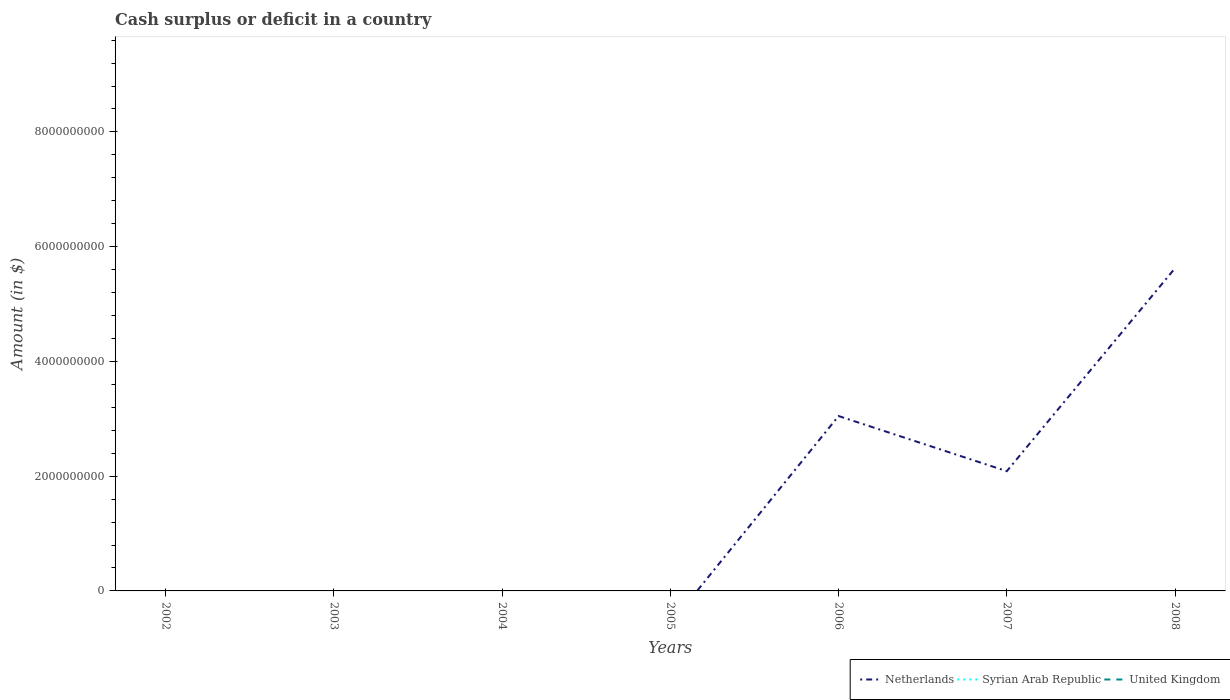Is the number of lines equal to the number of legend labels?
Offer a terse response. No. What is the difference between the highest and the second highest amount of cash surplus or deficit in Netherlands?
Ensure brevity in your answer.  5.62e+09. Is the amount of cash surplus or deficit in Netherlands strictly greater than the amount of cash surplus or deficit in Syrian Arab Republic over the years?
Ensure brevity in your answer.  No. Does the graph contain any zero values?
Your answer should be compact. Yes. Does the graph contain grids?
Your answer should be compact. No. How many legend labels are there?
Offer a terse response. 3. What is the title of the graph?
Keep it short and to the point. Cash surplus or deficit in a country. What is the label or title of the Y-axis?
Keep it short and to the point. Amount (in $). What is the Amount (in $) of Netherlands in 2003?
Give a very brief answer. 0. What is the Amount (in $) of Syrian Arab Republic in 2003?
Make the answer very short. 0. What is the Amount (in $) of United Kingdom in 2003?
Offer a terse response. 0. What is the Amount (in $) in United Kingdom in 2005?
Keep it short and to the point. 0. What is the Amount (in $) in Netherlands in 2006?
Give a very brief answer. 3.05e+09. What is the Amount (in $) of Syrian Arab Republic in 2006?
Your response must be concise. 0. What is the Amount (in $) of Netherlands in 2007?
Your answer should be very brief. 2.09e+09. What is the Amount (in $) in Syrian Arab Republic in 2007?
Ensure brevity in your answer.  0. What is the Amount (in $) of United Kingdom in 2007?
Keep it short and to the point. 0. What is the Amount (in $) of Netherlands in 2008?
Keep it short and to the point. 5.62e+09. Across all years, what is the maximum Amount (in $) in Netherlands?
Offer a terse response. 5.62e+09. Across all years, what is the minimum Amount (in $) of Netherlands?
Your answer should be compact. 0. What is the total Amount (in $) of Netherlands in the graph?
Offer a terse response. 1.08e+1. What is the total Amount (in $) in Syrian Arab Republic in the graph?
Offer a terse response. 0. What is the total Amount (in $) in United Kingdom in the graph?
Your answer should be very brief. 0. What is the difference between the Amount (in $) of Netherlands in 2006 and that in 2007?
Keep it short and to the point. 9.61e+08. What is the difference between the Amount (in $) in Netherlands in 2006 and that in 2008?
Make the answer very short. -2.58e+09. What is the difference between the Amount (in $) in Netherlands in 2007 and that in 2008?
Provide a succinct answer. -3.54e+09. What is the average Amount (in $) of Netherlands per year?
Give a very brief answer. 1.54e+09. What is the average Amount (in $) of Syrian Arab Republic per year?
Give a very brief answer. 0. What is the ratio of the Amount (in $) of Netherlands in 2006 to that in 2007?
Keep it short and to the point. 1.46. What is the ratio of the Amount (in $) of Netherlands in 2006 to that in 2008?
Your answer should be compact. 0.54. What is the ratio of the Amount (in $) in Netherlands in 2007 to that in 2008?
Provide a succinct answer. 0.37. What is the difference between the highest and the second highest Amount (in $) in Netherlands?
Make the answer very short. 2.58e+09. What is the difference between the highest and the lowest Amount (in $) of Netherlands?
Keep it short and to the point. 5.62e+09. 